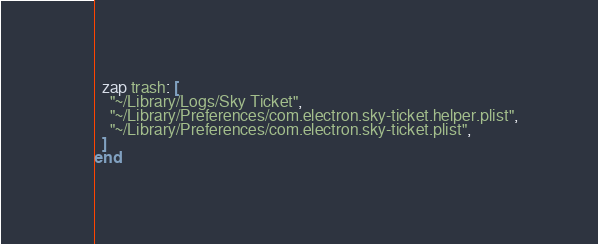Convert code to text. <code><loc_0><loc_0><loc_500><loc_500><_Ruby_>
  zap trash: [
    "~/Library/Logs/Sky Ticket",
    "~/Library/Preferences/com.electron.sky-ticket.helper.plist",
    "~/Library/Preferences/com.electron.sky-ticket.plist",
  ]
end
</code> 